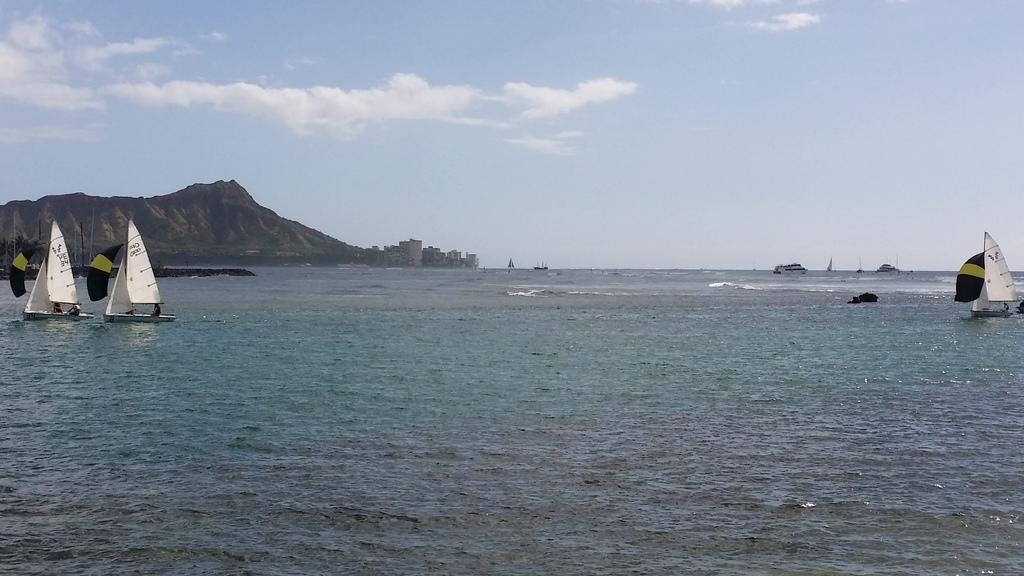What can be seen in the sky in the image? The sky with clouds is visible in the image. What type of natural landform is present in the image? There are hills in the image. What type of man-made structures are visible in the image? There are buildings in the image. What type of vehicles can be seen on the water in the image? There are ships on the water in the image. What type of ray is emitted from the buildings in the image? There is no mention of any rays being emitted from the buildings in the image. What type of division is taking place among the clouds in the image? There is no division taking place among the clouds in the image; they are simply visible in the sky. 